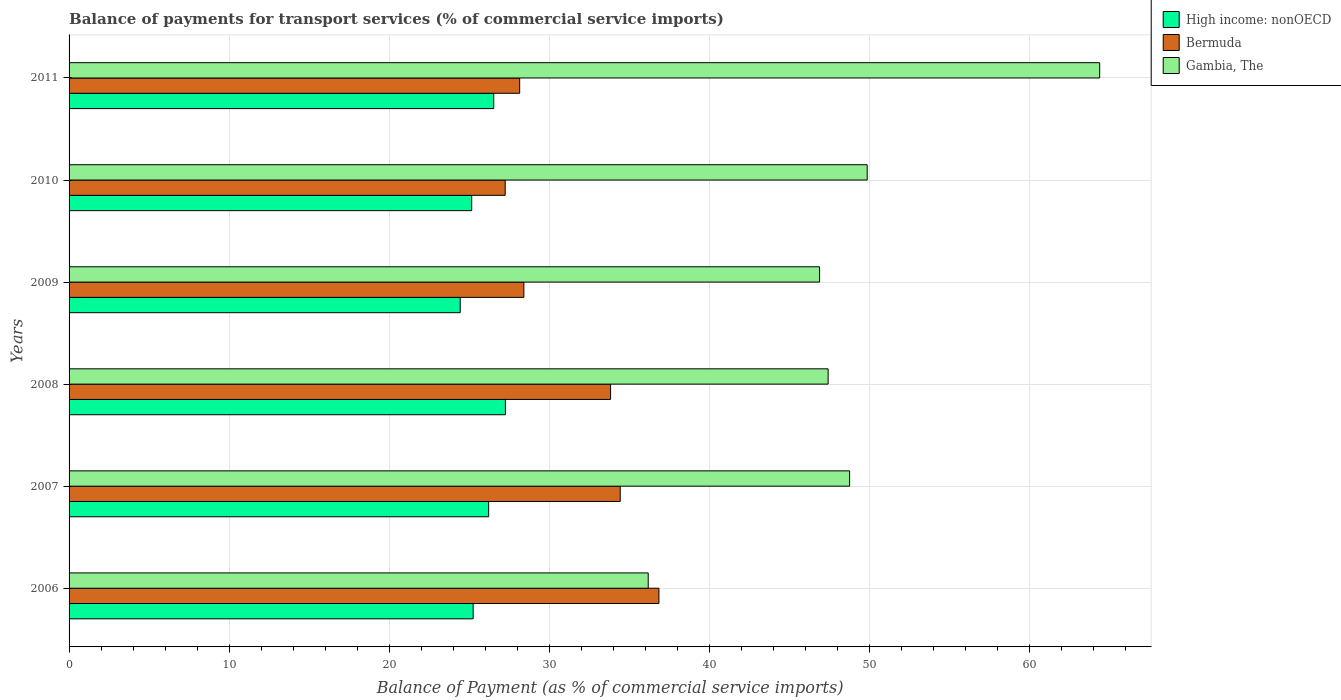How many different coloured bars are there?
Offer a very short reply. 3. How many groups of bars are there?
Provide a short and direct response. 6. In how many cases, is the number of bars for a given year not equal to the number of legend labels?
Offer a terse response. 0. What is the balance of payments for transport services in Gambia, The in 2006?
Your answer should be very brief. 36.18. Across all years, what is the maximum balance of payments for transport services in High income: nonOECD?
Make the answer very short. 27.26. Across all years, what is the minimum balance of payments for transport services in High income: nonOECD?
Keep it short and to the point. 24.44. In which year was the balance of payments for transport services in Bermuda minimum?
Offer a very short reply. 2010. What is the total balance of payments for transport services in Bermuda in the graph?
Give a very brief answer. 188.94. What is the difference between the balance of payments for transport services in High income: nonOECD in 2010 and that in 2011?
Keep it short and to the point. -1.38. What is the difference between the balance of payments for transport services in Gambia, The in 2006 and the balance of payments for transport services in Bermuda in 2009?
Keep it short and to the point. 7.77. What is the average balance of payments for transport services in Gambia, The per year?
Offer a very short reply. 48.92. In the year 2011, what is the difference between the balance of payments for transport services in High income: nonOECD and balance of payments for transport services in Bermuda?
Offer a very short reply. -1.62. In how many years, is the balance of payments for transport services in Gambia, The greater than 18 %?
Offer a terse response. 6. What is the ratio of the balance of payments for transport services in Bermuda in 2006 to that in 2008?
Offer a very short reply. 1.09. Is the balance of payments for transport services in Bermuda in 2007 less than that in 2008?
Ensure brevity in your answer.  No. What is the difference between the highest and the second highest balance of payments for transport services in Gambia, The?
Your answer should be compact. 14.52. What is the difference between the highest and the lowest balance of payments for transport services in Gambia, The?
Offer a very short reply. 28.21. In how many years, is the balance of payments for transport services in Gambia, The greater than the average balance of payments for transport services in Gambia, The taken over all years?
Offer a very short reply. 2. Is the sum of the balance of payments for transport services in Bermuda in 2010 and 2011 greater than the maximum balance of payments for transport services in High income: nonOECD across all years?
Provide a succinct answer. Yes. What does the 1st bar from the top in 2010 represents?
Your response must be concise. Gambia, The. What does the 3rd bar from the bottom in 2011 represents?
Keep it short and to the point. Gambia, The. How many bars are there?
Your answer should be compact. 18. Are all the bars in the graph horizontal?
Your response must be concise. Yes. How many years are there in the graph?
Ensure brevity in your answer.  6. What is the difference between two consecutive major ticks on the X-axis?
Your answer should be compact. 10. Does the graph contain any zero values?
Your answer should be compact. No. How many legend labels are there?
Provide a succinct answer. 3. What is the title of the graph?
Offer a very short reply. Balance of payments for transport services (% of commercial service imports). What is the label or title of the X-axis?
Keep it short and to the point. Balance of Payment (as % of commercial service imports). What is the label or title of the Y-axis?
Your answer should be compact. Years. What is the Balance of Payment (as % of commercial service imports) of High income: nonOECD in 2006?
Offer a very short reply. 25.25. What is the Balance of Payment (as % of commercial service imports) of Bermuda in 2006?
Give a very brief answer. 36.85. What is the Balance of Payment (as % of commercial service imports) in Gambia, The in 2006?
Offer a very short reply. 36.18. What is the Balance of Payment (as % of commercial service imports) in High income: nonOECD in 2007?
Provide a succinct answer. 26.21. What is the Balance of Payment (as % of commercial service imports) in Bermuda in 2007?
Offer a very short reply. 34.44. What is the Balance of Payment (as % of commercial service imports) in Gambia, The in 2007?
Provide a succinct answer. 48.77. What is the Balance of Payment (as % of commercial service imports) in High income: nonOECD in 2008?
Your answer should be very brief. 27.26. What is the Balance of Payment (as % of commercial service imports) of Bermuda in 2008?
Provide a short and direct response. 33.83. What is the Balance of Payment (as % of commercial service imports) of Gambia, The in 2008?
Provide a succinct answer. 47.43. What is the Balance of Payment (as % of commercial service imports) of High income: nonOECD in 2009?
Ensure brevity in your answer.  24.44. What is the Balance of Payment (as % of commercial service imports) in Bermuda in 2009?
Make the answer very short. 28.41. What is the Balance of Payment (as % of commercial service imports) in Gambia, The in 2009?
Offer a terse response. 46.89. What is the Balance of Payment (as % of commercial service imports) in High income: nonOECD in 2010?
Provide a short and direct response. 25.16. What is the Balance of Payment (as % of commercial service imports) in Bermuda in 2010?
Your answer should be compact. 27.25. What is the Balance of Payment (as % of commercial service imports) in Gambia, The in 2010?
Give a very brief answer. 49.87. What is the Balance of Payment (as % of commercial service imports) of High income: nonOECD in 2011?
Provide a short and direct response. 26.53. What is the Balance of Payment (as % of commercial service imports) in Bermuda in 2011?
Keep it short and to the point. 28.15. What is the Balance of Payment (as % of commercial service imports) of Gambia, The in 2011?
Offer a terse response. 64.39. Across all years, what is the maximum Balance of Payment (as % of commercial service imports) of High income: nonOECD?
Keep it short and to the point. 27.26. Across all years, what is the maximum Balance of Payment (as % of commercial service imports) in Bermuda?
Provide a short and direct response. 36.85. Across all years, what is the maximum Balance of Payment (as % of commercial service imports) in Gambia, The?
Make the answer very short. 64.39. Across all years, what is the minimum Balance of Payment (as % of commercial service imports) of High income: nonOECD?
Provide a short and direct response. 24.44. Across all years, what is the minimum Balance of Payment (as % of commercial service imports) in Bermuda?
Your response must be concise. 27.25. Across all years, what is the minimum Balance of Payment (as % of commercial service imports) of Gambia, The?
Provide a short and direct response. 36.18. What is the total Balance of Payment (as % of commercial service imports) of High income: nonOECD in the graph?
Your answer should be compact. 154.85. What is the total Balance of Payment (as % of commercial service imports) of Bermuda in the graph?
Give a very brief answer. 188.94. What is the total Balance of Payment (as % of commercial service imports) in Gambia, The in the graph?
Ensure brevity in your answer.  293.52. What is the difference between the Balance of Payment (as % of commercial service imports) of High income: nonOECD in 2006 and that in 2007?
Offer a terse response. -0.97. What is the difference between the Balance of Payment (as % of commercial service imports) of Bermuda in 2006 and that in 2007?
Make the answer very short. 2.42. What is the difference between the Balance of Payment (as % of commercial service imports) of Gambia, The in 2006 and that in 2007?
Offer a very short reply. -12.58. What is the difference between the Balance of Payment (as % of commercial service imports) in High income: nonOECD in 2006 and that in 2008?
Provide a short and direct response. -2.01. What is the difference between the Balance of Payment (as % of commercial service imports) in Bermuda in 2006 and that in 2008?
Your answer should be compact. 3.02. What is the difference between the Balance of Payment (as % of commercial service imports) in Gambia, The in 2006 and that in 2008?
Offer a terse response. -11.24. What is the difference between the Balance of Payment (as % of commercial service imports) of High income: nonOECD in 2006 and that in 2009?
Your response must be concise. 0.81. What is the difference between the Balance of Payment (as % of commercial service imports) of Bermuda in 2006 and that in 2009?
Your response must be concise. 8.44. What is the difference between the Balance of Payment (as % of commercial service imports) in Gambia, The in 2006 and that in 2009?
Offer a very short reply. -10.71. What is the difference between the Balance of Payment (as % of commercial service imports) in High income: nonOECD in 2006 and that in 2010?
Ensure brevity in your answer.  0.09. What is the difference between the Balance of Payment (as % of commercial service imports) in Bermuda in 2006 and that in 2010?
Your response must be concise. 9.61. What is the difference between the Balance of Payment (as % of commercial service imports) in Gambia, The in 2006 and that in 2010?
Keep it short and to the point. -13.68. What is the difference between the Balance of Payment (as % of commercial service imports) of High income: nonOECD in 2006 and that in 2011?
Your answer should be compact. -1.29. What is the difference between the Balance of Payment (as % of commercial service imports) of Bermuda in 2006 and that in 2011?
Provide a succinct answer. 8.7. What is the difference between the Balance of Payment (as % of commercial service imports) in Gambia, The in 2006 and that in 2011?
Your response must be concise. -28.21. What is the difference between the Balance of Payment (as % of commercial service imports) in High income: nonOECD in 2007 and that in 2008?
Offer a terse response. -1.05. What is the difference between the Balance of Payment (as % of commercial service imports) in Bermuda in 2007 and that in 2008?
Ensure brevity in your answer.  0.6. What is the difference between the Balance of Payment (as % of commercial service imports) of Gambia, The in 2007 and that in 2008?
Offer a terse response. 1.34. What is the difference between the Balance of Payment (as % of commercial service imports) in High income: nonOECD in 2007 and that in 2009?
Offer a very short reply. 1.78. What is the difference between the Balance of Payment (as % of commercial service imports) in Bermuda in 2007 and that in 2009?
Offer a very short reply. 6.02. What is the difference between the Balance of Payment (as % of commercial service imports) in Gambia, The in 2007 and that in 2009?
Offer a very short reply. 1.88. What is the difference between the Balance of Payment (as % of commercial service imports) of High income: nonOECD in 2007 and that in 2010?
Make the answer very short. 1.06. What is the difference between the Balance of Payment (as % of commercial service imports) in Bermuda in 2007 and that in 2010?
Your response must be concise. 7.19. What is the difference between the Balance of Payment (as % of commercial service imports) in Gambia, The in 2007 and that in 2010?
Provide a short and direct response. -1.1. What is the difference between the Balance of Payment (as % of commercial service imports) of High income: nonOECD in 2007 and that in 2011?
Offer a very short reply. -0.32. What is the difference between the Balance of Payment (as % of commercial service imports) in Bermuda in 2007 and that in 2011?
Provide a short and direct response. 6.28. What is the difference between the Balance of Payment (as % of commercial service imports) of Gambia, The in 2007 and that in 2011?
Ensure brevity in your answer.  -15.62. What is the difference between the Balance of Payment (as % of commercial service imports) of High income: nonOECD in 2008 and that in 2009?
Offer a terse response. 2.82. What is the difference between the Balance of Payment (as % of commercial service imports) in Bermuda in 2008 and that in 2009?
Provide a succinct answer. 5.42. What is the difference between the Balance of Payment (as % of commercial service imports) in Gambia, The in 2008 and that in 2009?
Offer a very short reply. 0.54. What is the difference between the Balance of Payment (as % of commercial service imports) in High income: nonOECD in 2008 and that in 2010?
Keep it short and to the point. 2.1. What is the difference between the Balance of Payment (as % of commercial service imports) in Bermuda in 2008 and that in 2010?
Keep it short and to the point. 6.58. What is the difference between the Balance of Payment (as % of commercial service imports) of Gambia, The in 2008 and that in 2010?
Give a very brief answer. -2.44. What is the difference between the Balance of Payment (as % of commercial service imports) in High income: nonOECD in 2008 and that in 2011?
Give a very brief answer. 0.73. What is the difference between the Balance of Payment (as % of commercial service imports) of Bermuda in 2008 and that in 2011?
Your answer should be very brief. 5.68. What is the difference between the Balance of Payment (as % of commercial service imports) in Gambia, The in 2008 and that in 2011?
Your response must be concise. -16.96. What is the difference between the Balance of Payment (as % of commercial service imports) in High income: nonOECD in 2009 and that in 2010?
Your answer should be compact. -0.72. What is the difference between the Balance of Payment (as % of commercial service imports) in Bermuda in 2009 and that in 2010?
Give a very brief answer. 1.17. What is the difference between the Balance of Payment (as % of commercial service imports) in Gambia, The in 2009 and that in 2010?
Your answer should be very brief. -2.98. What is the difference between the Balance of Payment (as % of commercial service imports) in High income: nonOECD in 2009 and that in 2011?
Ensure brevity in your answer.  -2.09. What is the difference between the Balance of Payment (as % of commercial service imports) of Bermuda in 2009 and that in 2011?
Offer a very short reply. 0.26. What is the difference between the Balance of Payment (as % of commercial service imports) in Gambia, The in 2009 and that in 2011?
Your answer should be very brief. -17.5. What is the difference between the Balance of Payment (as % of commercial service imports) of High income: nonOECD in 2010 and that in 2011?
Provide a short and direct response. -1.38. What is the difference between the Balance of Payment (as % of commercial service imports) in Bermuda in 2010 and that in 2011?
Give a very brief answer. -0.9. What is the difference between the Balance of Payment (as % of commercial service imports) of Gambia, The in 2010 and that in 2011?
Keep it short and to the point. -14.52. What is the difference between the Balance of Payment (as % of commercial service imports) in High income: nonOECD in 2006 and the Balance of Payment (as % of commercial service imports) in Bermuda in 2007?
Keep it short and to the point. -9.19. What is the difference between the Balance of Payment (as % of commercial service imports) in High income: nonOECD in 2006 and the Balance of Payment (as % of commercial service imports) in Gambia, The in 2007?
Your response must be concise. -23.52. What is the difference between the Balance of Payment (as % of commercial service imports) in Bermuda in 2006 and the Balance of Payment (as % of commercial service imports) in Gambia, The in 2007?
Offer a terse response. -11.91. What is the difference between the Balance of Payment (as % of commercial service imports) in High income: nonOECD in 2006 and the Balance of Payment (as % of commercial service imports) in Bermuda in 2008?
Give a very brief answer. -8.59. What is the difference between the Balance of Payment (as % of commercial service imports) in High income: nonOECD in 2006 and the Balance of Payment (as % of commercial service imports) in Gambia, The in 2008?
Keep it short and to the point. -22.18. What is the difference between the Balance of Payment (as % of commercial service imports) of Bermuda in 2006 and the Balance of Payment (as % of commercial service imports) of Gambia, The in 2008?
Offer a very short reply. -10.57. What is the difference between the Balance of Payment (as % of commercial service imports) in High income: nonOECD in 2006 and the Balance of Payment (as % of commercial service imports) in Bermuda in 2009?
Your answer should be compact. -3.17. What is the difference between the Balance of Payment (as % of commercial service imports) in High income: nonOECD in 2006 and the Balance of Payment (as % of commercial service imports) in Gambia, The in 2009?
Make the answer very short. -21.64. What is the difference between the Balance of Payment (as % of commercial service imports) in Bermuda in 2006 and the Balance of Payment (as % of commercial service imports) in Gambia, The in 2009?
Your answer should be compact. -10.04. What is the difference between the Balance of Payment (as % of commercial service imports) of High income: nonOECD in 2006 and the Balance of Payment (as % of commercial service imports) of Bermuda in 2010?
Ensure brevity in your answer.  -2. What is the difference between the Balance of Payment (as % of commercial service imports) in High income: nonOECD in 2006 and the Balance of Payment (as % of commercial service imports) in Gambia, The in 2010?
Your response must be concise. -24.62. What is the difference between the Balance of Payment (as % of commercial service imports) in Bermuda in 2006 and the Balance of Payment (as % of commercial service imports) in Gambia, The in 2010?
Keep it short and to the point. -13.01. What is the difference between the Balance of Payment (as % of commercial service imports) in High income: nonOECD in 2006 and the Balance of Payment (as % of commercial service imports) in Bermuda in 2011?
Ensure brevity in your answer.  -2.91. What is the difference between the Balance of Payment (as % of commercial service imports) in High income: nonOECD in 2006 and the Balance of Payment (as % of commercial service imports) in Gambia, The in 2011?
Provide a succinct answer. -39.14. What is the difference between the Balance of Payment (as % of commercial service imports) in Bermuda in 2006 and the Balance of Payment (as % of commercial service imports) in Gambia, The in 2011?
Give a very brief answer. -27.54. What is the difference between the Balance of Payment (as % of commercial service imports) of High income: nonOECD in 2007 and the Balance of Payment (as % of commercial service imports) of Bermuda in 2008?
Keep it short and to the point. -7.62. What is the difference between the Balance of Payment (as % of commercial service imports) in High income: nonOECD in 2007 and the Balance of Payment (as % of commercial service imports) in Gambia, The in 2008?
Give a very brief answer. -21.21. What is the difference between the Balance of Payment (as % of commercial service imports) in Bermuda in 2007 and the Balance of Payment (as % of commercial service imports) in Gambia, The in 2008?
Your answer should be very brief. -12.99. What is the difference between the Balance of Payment (as % of commercial service imports) of High income: nonOECD in 2007 and the Balance of Payment (as % of commercial service imports) of Bermuda in 2009?
Your response must be concise. -2.2. What is the difference between the Balance of Payment (as % of commercial service imports) in High income: nonOECD in 2007 and the Balance of Payment (as % of commercial service imports) in Gambia, The in 2009?
Your response must be concise. -20.68. What is the difference between the Balance of Payment (as % of commercial service imports) in Bermuda in 2007 and the Balance of Payment (as % of commercial service imports) in Gambia, The in 2009?
Keep it short and to the point. -12.46. What is the difference between the Balance of Payment (as % of commercial service imports) in High income: nonOECD in 2007 and the Balance of Payment (as % of commercial service imports) in Bermuda in 2010?
Keep it short and to the point. -1.03. What is the difference between the Balance of Payment (as % of commercial service imports) in High income: nonOECD in 2007 and the Balance of Payment (as % of commercial service imports) in Gambia, The in 2010?
Your response must be concise. -23.65. What is the difference between the Balance of Payment (as % of commercial service imports) in Bermuda in 2007 and the Balance of Payment (as % of commercial service imports) in Gambia, The in 2010?
Make the answer very short. -15.43. What is the difference between the Balance of Payment (as % of commercial service imports) of High income: nonOECD in 2007 and the Balance of Payment (as % of commercial service imports) of Bermuda in 2011?
Provide a succinct answer. -1.94. What is the difference between the Balance of Payment (as % of commercial service imports) in High income: nonOECD in 2007 and the Balance of Payment (as % of commercial service imports) in Gambia, The in 2011?
Provide a short and direct response. -38.18. What is the difference between the Balance of Payment (as % of commercial service imports) of Bermuda in 2007 and the Balance of Payment (as % of commercial service imports) of Gambia, The in 2011?
Make the answer very short. -29.96. What is the difference between the Balance of Payment (as % of commercial service imports) in High income: nonOECD in 2008 and the Balance of Payment (as % of commercial service imports) in Bermuda in 2009?
Keep it short and to the point. -1.15. What is the difference between the Balance of Payment (as % of commercial service imports) in High income: nonOECD in 2008 and the Balance of Payment (as % of commercial service imports) in Gambia, The in 2009?
Keep it short and to the point. -19.63. What is the difference between the Balance of Payment (as % of commercial service imports) of Bermuda in 2008 and the Balance of Payment (as % of commercial service imports) of Gambia, The in 2009?
Keep it short and to the point. -13.06. What is the difference between the Balance of Payment (as % of commercial service imports) of High income: nonOECD in 2008 and the Balance of Payment (as % of commercial service imports) of Bermuda in 2010?
Provide a succinct answer. 0.01. What is the difference between the Balance of Payment (as % of commercial service imports) in High income: nonOECD in 2008 and the Balance of Payment (as % of commercial service imports) in Gambia, The in 2010?
Ensure brevity in your answer.  -22.61. What is the difference between the Balance of Payment (as % of commercial service imports) of Bermuda in 2008 and the Balance of Payment (as % of commercial service imports) of Gambia, The in 2010?
Your answer should be compact. -16.03. What is the difference between the Balance of Payment (as % of commercial service imports) in High income: nonOECD in 2008 and the Balance of Payment (as % of commercial service imports) in Bermuda in 2011?
Provide a succinct answer. -0.89. What is the difference between the Balance of Payment (as % of commercial service imports) of High income: nonOECD in 2008 and the Balance of Payment (as % of commercial service imports) of Gambia, The in 2011?
Your response must be concise. -37.13. What is the difference between the Balance of Payment (as % of commercial service imports) of Bermuda in 2008 and the Balance of Payment (as % of commercial service imports) of Gambia, The in 2011?
Keep it short and to the point. -30.56. What is the difference between the Balance of Payment (as % of commercial service imports) of High income: nonOECD in 2009 and the Balance of Payment (as % of commercial service imports) of Bermuda in 2010?
Your answer should be very brief. -2.81. What is the difference between the Balance of Payment (as % of commercial service imports) in High income: nonOECD in 2009 and the Balance of Payment (as % of commercial service imports) in Gambia, The in 2010?
Keep it short and to the point. -25.43. What is the difference between the Balance of Payment (as % of commercial service imports) in Bermuda in 2009 and the Balance of Payment (as % of commercial service imports) in Gambia, The in 2010?
Provide a short and direct response. -21.45. What is the difference between the Balance of Payment (as % of commercial service imports) of High income: nonOECD in 2009 and the Balance of Payment (as % of commercial service imports) of Bermuda in 2011?
Provide a succinct answer. -3.71. What is the difference between the Balance of Payment (as % of commercial service imports) of High income: nonOECD in 2009 and the Balance of Payment (as % of commercial service imports) of Gambia, The in 2011?
Keep it short and to the point. -39.95. What is the difference between the Balance of Payment (as % of commercial service imports) in Bermuda in 2009 and the Balance of Payment (as % of commercial service imports) in Gambia, The in 2011?
Your response must be concise. -35.98. What is the difference between the Balance of Payment (as % of commercial service imports) of High income: nonOECD in 2010 and the Balance of Payment (as % of commercial service imports) of Bermuda in 2011?
Your response must be concise. -3. What is the difference between the Balance of Payment (as % of commercial service imports) in High income: nonOECD in 2010 and the Balance of Payment (as % of commercial service imports) in Gambia, The in 2011?
Ensure brevity in your answer.  -39.23. What is the difference between the Balance of Payment (as % of commercial service imports) of Bermuda in 2010 and the Balance of Payment (as % of commercial service imports) of Gambia, The in 2011?
Your answer should be compact. -37.14. What is the average Balance of Payment (as % of commercial service imports) in High income: nonOECD per year?
Your answer should be very brief. 25.81. What is the average Balance of Payment (as % of commercial service imports) of Bermuda per year?
Your response must be concise. 31.49. What is the average Balance of Payment (as % of commercial service imports) in Gambia, The per year?
Keep it short and to the point. 48.92. In the year 2006, what is the difference between the Balance of Payment (as % of commercial service imports) of High income: nonOECD and Balance of Payment (as % of commercial service imports) of Bermuda?
Offer a very short reply. -11.61. In the year 2006, what is the difference between the Balance of Payment (as % of commercial service imports) in High income: nonOECD and Balance of Payment (as % of commercial service imports) in Gambia, The?
Offer a very short reply. -10.94. In the year 2006, what is the difference between the Balance of Payment (as % of commercial service imports) in Bermuda and Balance of Payment (as % of commercial service imports) in Gambia, The?
Offer a very short reply. 0.67. In the year 2007, what is the difference between the Balance of Payment (as % of commercial service imports) of High income: nonOECD and Balance of Payment (as % of commercial service imports) of Bermuda?
Ensure brevity in your answer.  -8.22. In the year 2007, what is the difference between the Balance of Payment (as % of commercial service imports) in High income: nonOECD and Balance of Payment (as % of commercial service imports) in Gambia, The?
Provide a short and direct response. -22.55. In the year 2007, what is the difference between the Balance of Payment (as % of commercial service imports) in Bermuda and Balance of Payment (as % of commercial service imports) in Gambia, The?
Your answer should be compact. -14.33. In the year 2008, what is the difference between the Balance of Payment (as % of commercial service imports) in High income: nonOECD and Balance of Payment (as % of commercial service imports) in Bermuda?
Provide a succinct answer. -6.57. In the year 2008, what is the difference between the Balance of Payment (as % of commercial service imports) of High income: nonOECD and Balance of Payment (as % of commercial service imports) of Gambia, The?
Make the answer very short. -20.16. In the year 2008, what is the difference between the Balance of Payment (as % of commercial service imports) of Bermuda and Balance of Payment (as % of commercial service imports) of Gambia, The?
Provide a short and direct response. -13.59. In the year 2009, what is the difference between the Balance of Payment (as % of commercial service imports) in High income: nonOECD and Balance of Payment (as % of commercial service imports) in Bermuda?
Make the answer very short. -3.98. In the year 2009, what is the difference between the Balance of Payment (as % of commercial service imports) in High income: nonOECD and Balance of Payment (as % of commercial service imports) in Gambia, The?
Offer a terse response. -22.45. In the year 2009, what is the difference between the Balance of Payment (as % of commercial service imports) in Bermuda and Balance of Payment (as % of commercial service imports) in Gambia, The?
Your answer should be very brief. -18.48. In the year 2010, what is the difference between the Balance of Payment (as % of commercial service imports) in High income: nonOECD and Balance of Payment (as % of commercial service imports) in Bermuda?
Keep it short and to the point. -2.09. In the year 2010, what is the difference between the Balance of Payment (as % of commercial service imports) of High income: nonOECD and Balance of Payment (as % of commercial service imports) of Gambia, The?
Provide a succinct answer. -24.71. In the year 2010, what is the difference between the Balance of Payment (as % of commercial service imports) of Bermuda and Balance of Payment (as % of commercial service imports) of Gambia, The?
Provide a short and direct response. -22.62. In the year 2011, what is the difference between the Balance of Payment (as % of commercial service imports) in High income: nonOECD and Balance of Payment (as % of commercial service imports) in Bermuda?
Your response must be concise. -1.62. In the year 2011, what is the difference between the Balance of Payment (as % of commercial service imports) of High income: nonOECD and Balance of Payment (as % of commercial service imports) of Gambia, The?
Ensure brevity in your answer.  -37.86. In the year 2011, what is the difference between the Balance of Payment (as % of commercial service imports) of Bermuda and Balance of Payment (as % of commercial service imports) of Gambia, The?
Keep it short and to the point. -36.24. What is the ratio of the Balance of Payment (as % of commercial service imports) of High income: nonOECD in 2006 to that in 2007?
Ensure brevity in your answer.  0.96. What is the ratio of the Balance of Payment (as % of commercial service imports) in Bermuda in 2006 to that in 2007?
Ensure brevity in your answer.  1.07. What is the ratio of the Balance of Payment (as % of commercial service imports) in Gambia, The in 2006 to that in 2007?
Your answer should be very brief. 0.74. What is the ratio of the Balance of Payment (as % of commercial service imports) of High income: nonOECD in 2006 to that in 2008?
Keep it short and to the point. 0.93. What is the ratio of the Balance of Payment (as % of commercial service imports) in Bermuda in 2006 to that in 2008?
Your response must be concise. 1.09. What is the ratio of the Balance of Payment (as % of commercial service imports) of Gambia, The in 2006 to that in 2008?
Keep it short and to the point. 0.76. What is the ratio of the Balance of Payment (as % of commercial service imports) in High income: nonOECD in 2006 to that in 2009?
Give a very brief answer. 1.03. What is the ratio of the Balance of Payment (as % of commercial service imports) in Bermuda in 2006 to that in 2009?
Ensure brevity in your answer.  1.3. What is the ratio of the Balance of Payment (as % of commercial service imports) of Gambia, The in 2006 to that in 2009?
Your answer should be compact. 0.77. What is the ratio of the Balance of Payment (as % of commercial service imports) in Bermuda in 2006 to that in 2010?
Ensure brevity in your answer.  1.35. What is the ratio of the Balance of Payment (as % of commercial service imports) of Gambia, The in 2006 to that in 2010?
Give a very brief answer. 0.73. What is the ratio of the Balance of Payment (as % of commercial service imports) of High income: nonOECD in 2006 to that in 2011?
Your answer should be very brief. 0.95. What is the ratio of the Balance of Payment (as % of commercial service imports) of Bermuda in 2006 to that in 2011?
Provide a succinct answer. 1.31. What is the ratio of the Balance of Payment (as % of commercial service imports) of Gambia, The in 2006 to that in 2011?
Make the answer very short. 0.56. What is the ratio of the Balance of Payment (as % of commercial service imports) in High income: nonOECD in 2007 to that in 2008?
Make the answer very short. 0.96. What is the ratio of the Balance of Payment (as % of commercial service imports) of Bermuda in 2007 to that in 2008?
Give a very brief answer. 1.02. What is the ratio of the Balance of Payment (as % of commercial service imports) of Gambia, The in 2007 to that in 2008?
Keep it short and to the point. 1.03. What is the ratio of the Balance of Payment (as % of commercial service imports) in High income: nonOECD in 2007 to that in 2009?
Ensure brevity in your answer.  1.07. What is the ratio of the Balance of Payment (as % of commercial service imports) in Bermuda in 2007 to that in 2009?
Your answer should be very brief. 1.21. What is the ratio of the Balance of Payment (as % of commercial service imports) of Gambia, The in 2007 to that in 2009?
Your answer should be very brief. 1.04. What is the ratio of the Balance of Payment (as % of commercial service imports) of High income: nonOECD in 2007 to that in 2010?
Make the answer very short. 1.04. What is the ratio of the Balance of Payment (as % of commercial service imports) in Bermuda in 2007 to that in 2010?
Your response must be concise. 1.26. What is the ratio of the Balance of Payment (as % of commercial service imports) in Bermuda in 2007 to that in 2011?
Ensure brevity in your answer.  1.22. What is the ratio of the Balance of Payment (as % of commercial service imports) in Gambia, The in 2007 to that in 2011?
Keep it short and to the point. 0.76. What is the ratio of the Balance of Payment (as % of commercial service imports) in High income: nonOECD in 2008 to that in 2009?
Your response must be concise. 1.12. What is the ratio of the Balance of Payment (as % of commercial service imports) in Bermuda in 2008 to that in 2009?
Offer a very short reply. 1.19. What is the ratio of the Balance of Payment (as % of commercial service imports) of Gambia, The in 2008 to that in 2009?
Provide a short and direct response. 1.01. What is the ratio of the Balance of Payment (as % of commercial service imports) in High income: nonOECD in 2008 to that in 2010?
Give a very brief answer. 1.08. What is the ratio of the Balance of Payment (as % of commercial service imports) in Bermuda in 2008 to that in 2010?
Your response must be concise. 1.24. What is the ratio of the Balance of Payment (as % of commercial service imports) in Gambia, The in 2008 to that in 2010?
Offer a very short reply. 0.95. What is the ratio of the Balance of Payment (as % of commercial service imports) in High income: nonOECD in 2008 to that in 2011?
Your response must be concise. 1.03. What is the ratio of the Balance of Payment (as % of commercial service imports) in Bermuda in 2008 to that in 2011?
Ensure brevity in your answer.  1.2. What is the ratio of the Balance of Payment (as % of commercial service imports) of Gambia, The in 2008 to that in 2011?
Your answer should be very brief. 0.74. What is the ratio of the Balance of Payment (as % of commercial service imports) in High income: nonOECD in 2009 to that in 2010?
Keep it short and to the point. 0.97. What is the ratio of the Balance of Payment (as % of commercial service imports) in Bermuda in 2009 to that in 2010?
Make the answer very short. 1.04. What is the ratio of the Balance of Payment (as % of commercial service imports) of Gambia, The in 2009 to that in 2010?
Give a very brief answer. 0.94. What is the ratio of the Balance of Payment (as % of commercial service imports) of High income: nonOECD in 2009 to that in 2011?
Make the answer very short. 0.92. What is the ratio of the Balance of Payment (as % of commercial service imports) of Bermuda in 2009 to that in 2011?
Your response must be concise. 1.01. What is the ratio of the Balance of Payment (as % of commercial service imports) in Gambia, The in 2009 to that in 2011?
Keep it short and to the point. 0.73. What is the ratio of the Balance of Payment (as % of commercial service imports) in High income: nonOECD in 2010 to that in 2011?
Give a very brief answer. 0.95. What is the ratio of the Balance of Payment (as % of commercial service imports) in Bermuda in 2010 to that in 2011?
Your response must be concise. 0.97. What is the ratio of the Balance of Payment (as % of commercial service imports) in Gambia, The in 2010 to that in 2011?
Provide a short and direct response. 0.77. What is the difference between the highest and the second highest Balance of Payment (as % of commercial service imports) in High income: nonOECD?
Your response must be concise. 0.73. What is the difference between the highest and the second highest Balance of Payment (as % of commercial service imports) in Bermuda?
Offer a very short reply. 2.42. What is the difference between the highest and the second highest Balance of Payment (as % of commercial service imports) in Gambia, The?
Give a very brief answer. 14.52. What is the difference between the highest and the lowest Balance of Payment (as % of commercial service imports) in High income: nonOECD?
Give a very brief answer. 2.82. What is the difference between the highest and the lowest Balance of Payment (as % of commercial service imports) in Bermuda?
Offer a very short reply. 9.61. What is the difference between the highest and the lowest Balance of Payment (as % of commercial service imports) of Gambia, The?
Your response must be concise. 28.21. 